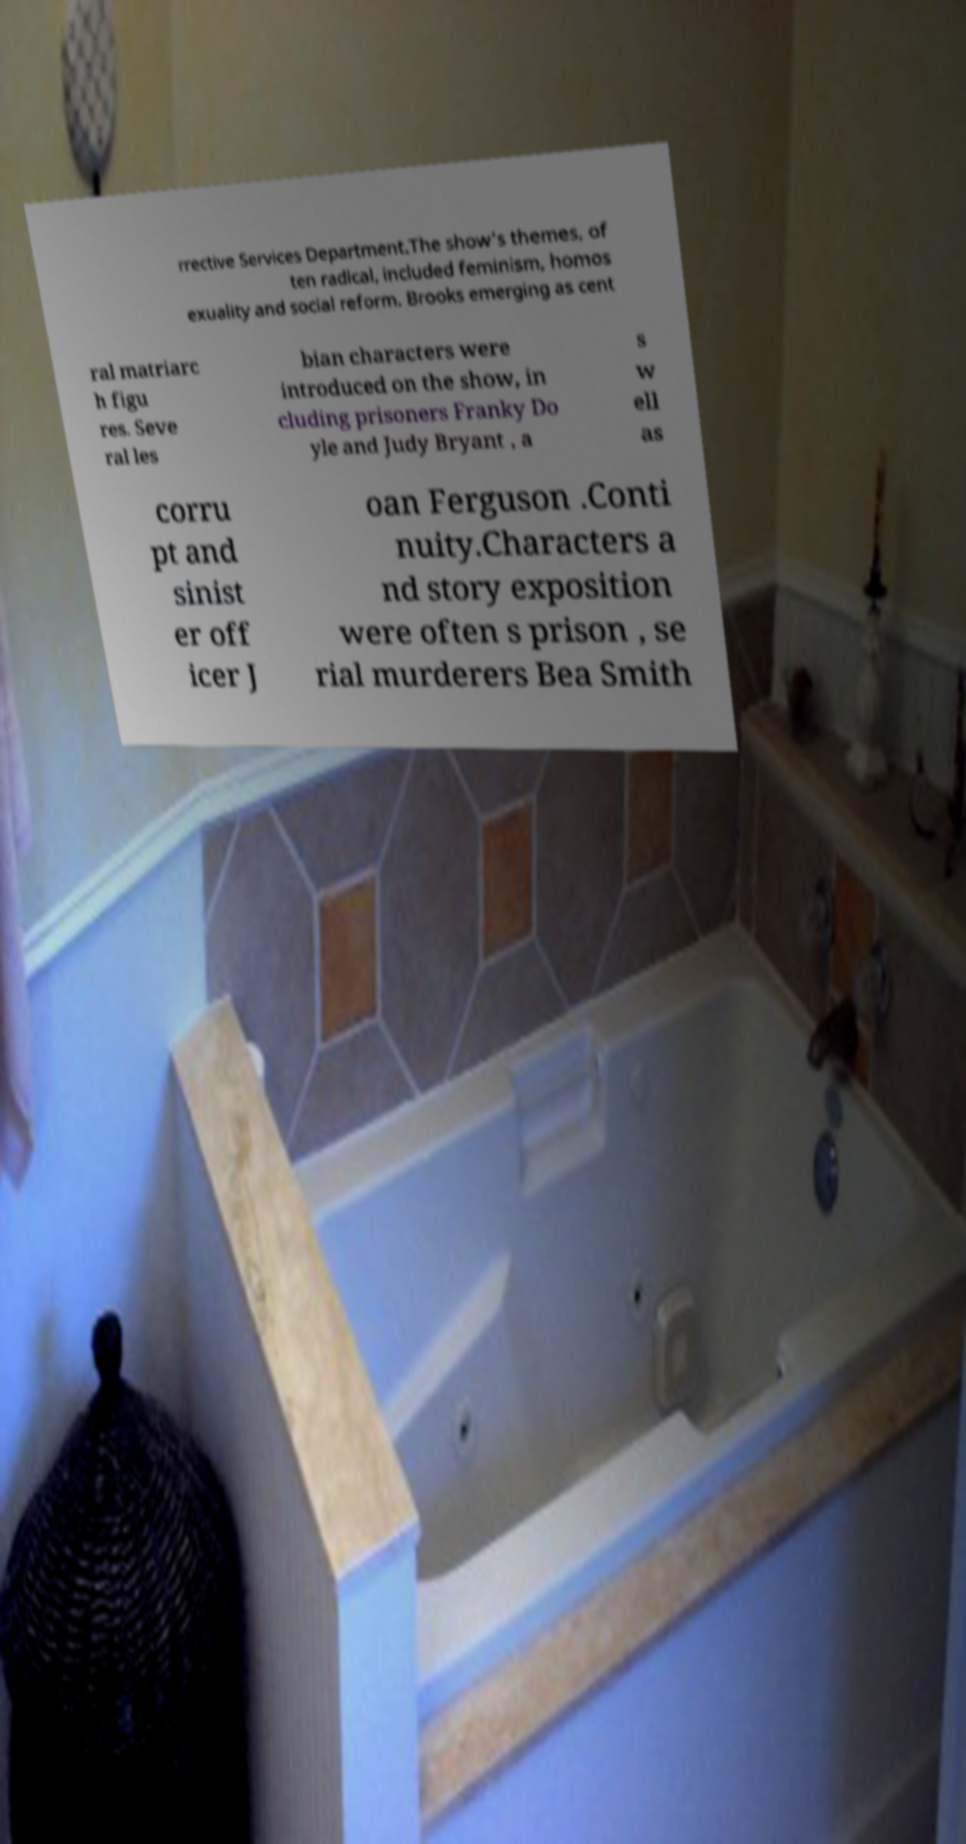Could you extract and type out the text from this image? rrective Services Department.The show's themes, of ten radical, included feminism, homos exuality and social reform. Brooks emerging as cent ral matriarc h figu res. Seve ral les bian characters were introduced on the show, in cluding prisoners Franky Do yle and Judy Bryant , a s w ell as corru pt and sinist er off icer J oan Ferguson .Conti nuity.Characters a nd story exposition were often s prison , se rial murderers Bea Smith 